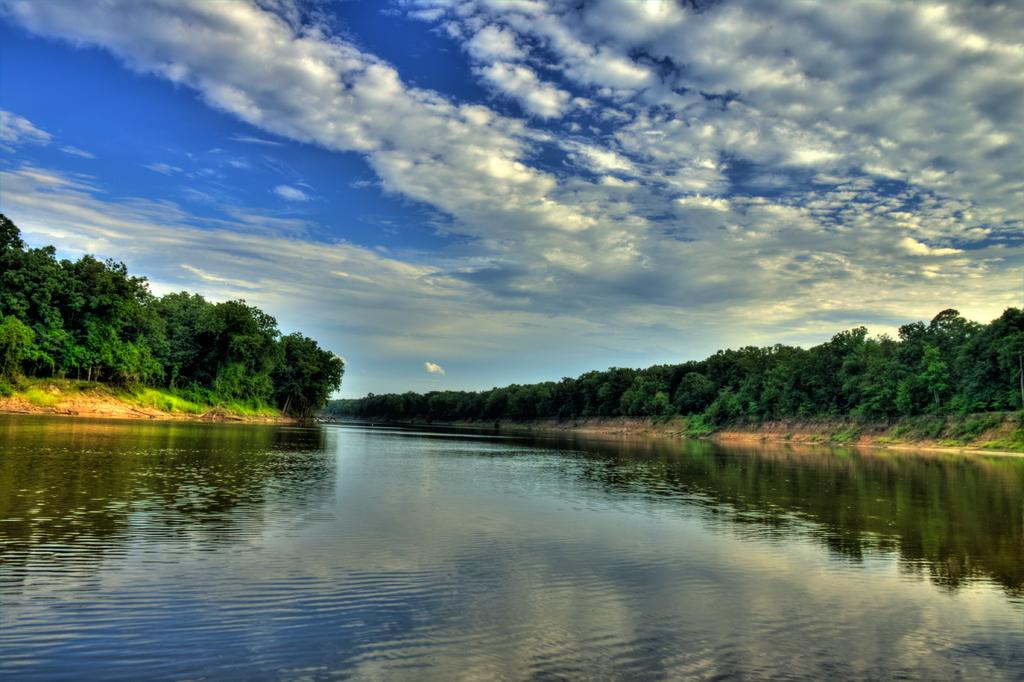What is the main element in the image? There is water in the image. What type of vegetation is present on either side of the water? There are trees on either side of the water. What type of ground cover is visible in the image? There is grass on the ground in the image. What is visible at the top of the image? The sky is visible at the top of the image. What can be seen in the sky? There are clouds in the sky. How many dimes are floating on the water in the image? There are no dimes visible in the image; it only features water, trees, grass, sky, and clouds. 